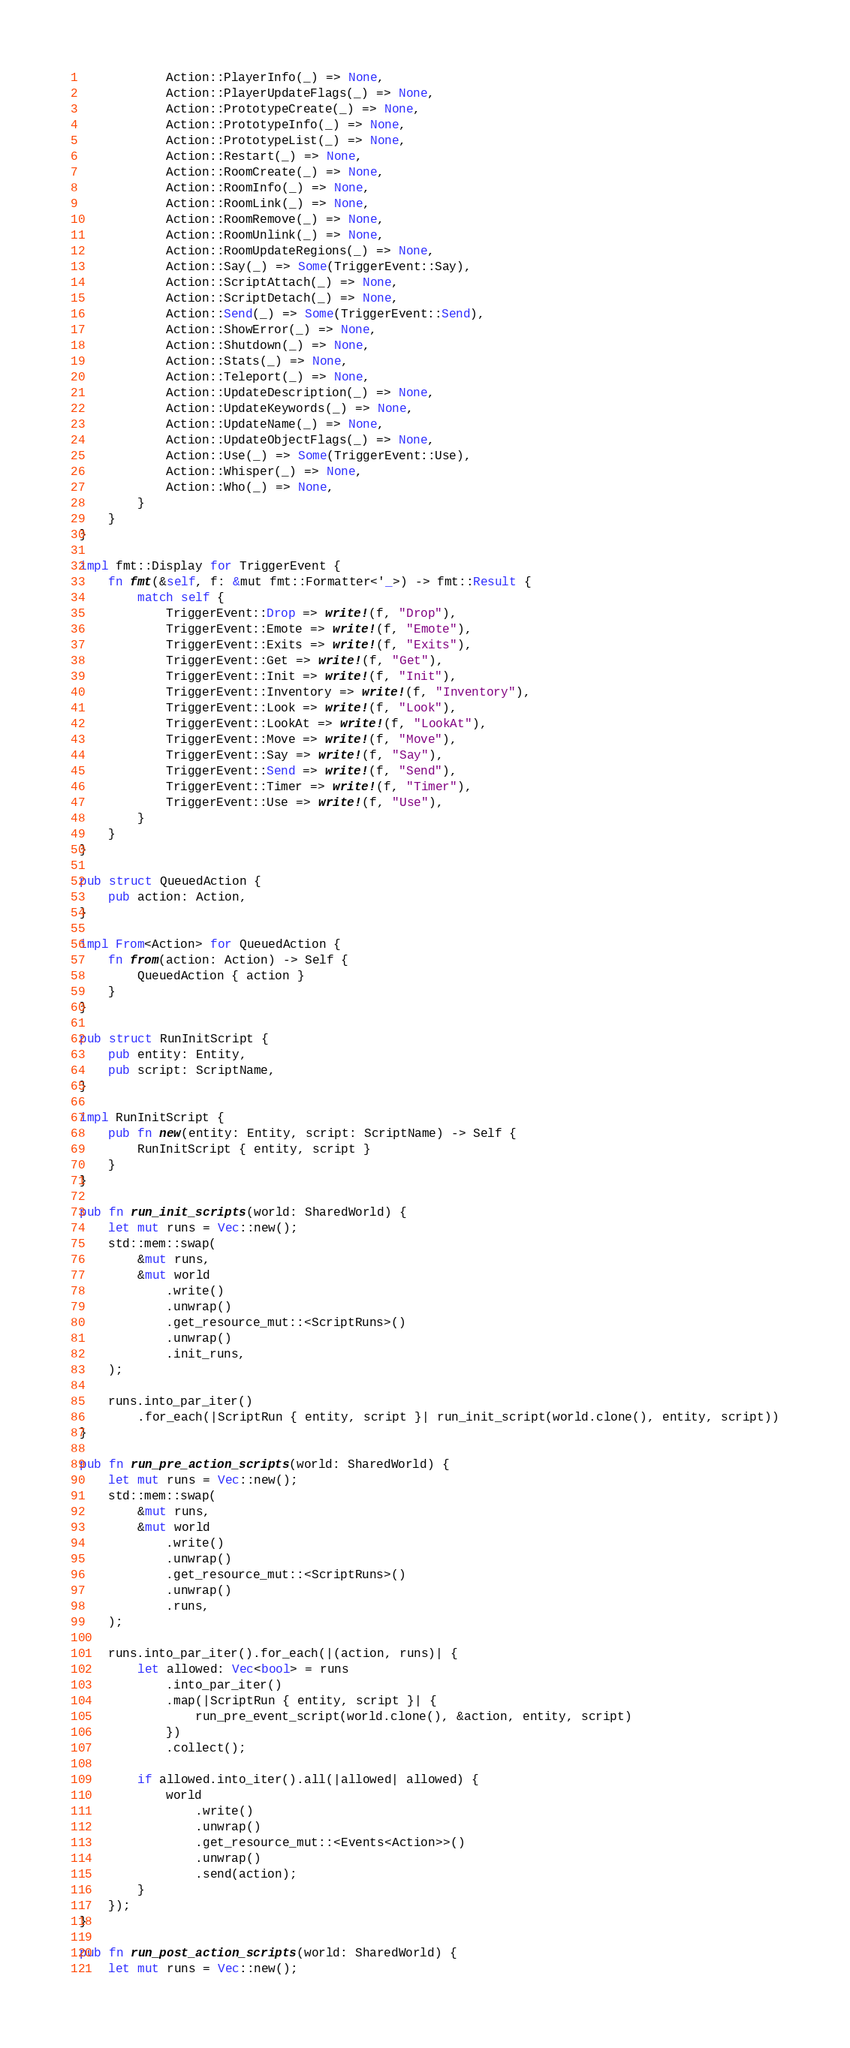<code> <loc_0><loc_0><loc_500><loc_500><_Rust_>            Action::PlayerInfo(_) => None,
            Action::PlayerUpdateFlags(_) => None,
            Action::PrototypeCreate(_) => None,
            Action::PrototypeInfo(_) => None,
            Action::PrototypeList(_) => None,
            Action::Restart(_) => None,
            Action::RoomCreate(_) => None,
            Action::RoomInfo(_) => None,
            Action::RoomLink(_) => None,
            Action::RoomRemove(_) => None,
            Action::RoomUnlink(_) => None,
            Action::RoomUpdateRegions(_) => None,
            Action::Say(_) => Some(TriggerEvent::Say),
            Action::ScriptAttach(_) => None,
            Action::ScriptDetach(_) => None,
            Action::Send(_) => Some(TriggerEvent::Send),
            Action::ShowError(_) => None,
            Action::Shutdown(_) => None,
            Action::Stats(_) => None,
            Action::Teleport(_) => None,
            Action::UpdateDescription(_) => None,
            Action::UpdateKeywords(_) => None,
            Action::UpdateName(_) => None,
            Action::UpdateObjectFlags(_) => None,
            Action::Use(_) => Some(TriggerEvent::Use),
            Action::Whisper(_) => None,
            Action::Who(_) => None,
        }
    }
}

impl fmt::Display for TriggerEvent {
    fn fmt(&self, f: &mut fmt::Formatter<'_>) -> fmt::Result {
        match self {
            TriggerEvent::Drop => write!(f, "Drop"),
            TriggerEvent::Emote => write!(f, "Emote"),
            TriggerEvent::Exits => write!(f, "Exits"),
            TriggerEvent::Get => write!(f, "Get"),
            TriggerEvent::Init => write!(f, "Init"),
            TriggerEvent::Inventory => write!(f, "Inventory"),
            TriggerEvent::Look => write!(f, "Look"),
            TriggerEvent::LookAt => write!(f, "LookAt"),
            TriggerEvent::Move => write!(f, "Move"),
            TriggerEvent::Say => write!(f, "Say"),
            TriggerEvent::Send => write!(f, "Send"),
            TriggerEvent::Timer => write!(f, "Timer"),
            TriggerEvent::Use => write!(f, "Use"),
        }
    }
}

pub struct QueuedAction {
    pub action: Action,
}

impl From<Action> for QueuedAction {
    fn from(action: Action) -> Self {
        QueuedAction { action }
    }
}

pub struct RunInitScript {
    pub entity: Entity,
    pub script: ScriptName,
}

impl RunInitScript {
    pub fn new(entity: Entity, script: ScriptName) -> Self {
        RunInitScript { entity, script }
    }
}

pub fn run_init_scripts(world: SharedWorld) {
    let mut runs = Vec::new();
    std::mem::swap(
        &mut runs,
        &mut world
            .write()
            .unwrap()
            .get_resource_mut::<ScriptRuns>()
            .unwrap()
            .init_runs,
    );

    runs.into_par_iter()
        .for_each(|ScriptRun { entity, script }| run_init_script(world.clone(), entity, script))
}

pub fn run_pre_action_scripts(world: SharedWorld) {
    let mut runs = Vec::new();
    std::mem::swap(
        &mut runs,
        &mut world
            .write()
            .unwrap()
            .get_resource_mut::<ScriptRuns>()
            .unwrap()
            .runs,
    );

    runs.into_par_iter().for_each(|(action, runs)| {
        let allowed: Vec<bool> = runs
            .into_par_iter()
            .map(|ScriptRun { entity, script }| {
                run_pre_event_script(world.clone(), &action, entity, script)
            })
            .collect();

        if allowed.into_iter().all(|allowed| allowed) {
            world
                .write()
                .unwrap()
                .get_resource_mut::<Events<Action>>()
                .unwrap()
                .send(action);
        }
    });
}

pub fn run_post_action_scripts(world: SharedWorld) {
    let mut runs = Vec::new();</code> 